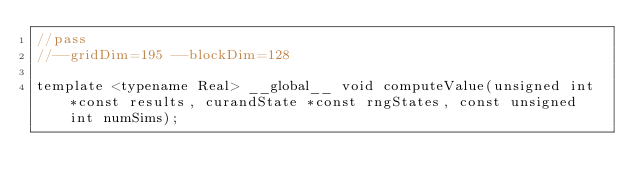Convert code to text. <code><loc_0><loc_0><loc_500><loc_500><_Cuda_>//pass
//--gridDim=195 --blockDim=128

template <typename Real> __global__ void computeValue(unsigned int *const results, curandState *const rngStates, const unsigned int numSims);</code> 